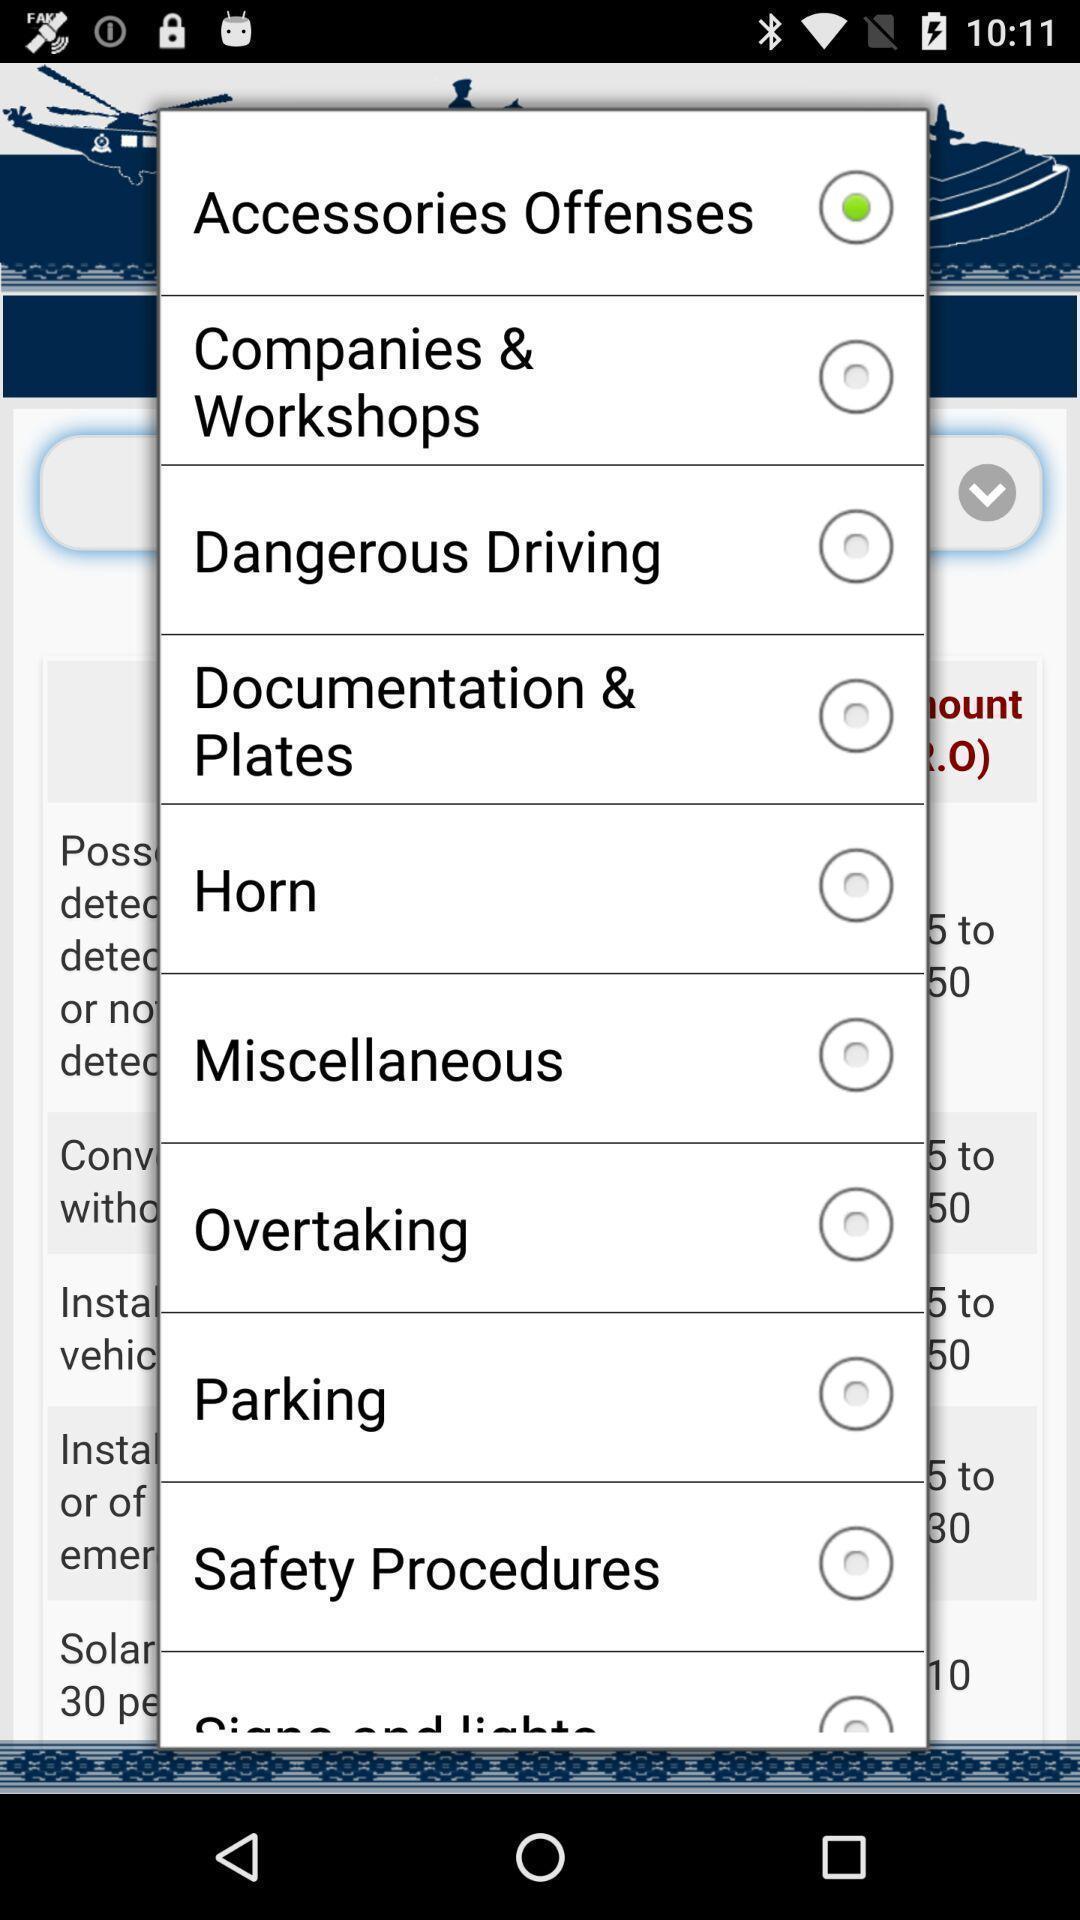Tell me what you see in this picture. Pop-up displaying with different categories. 